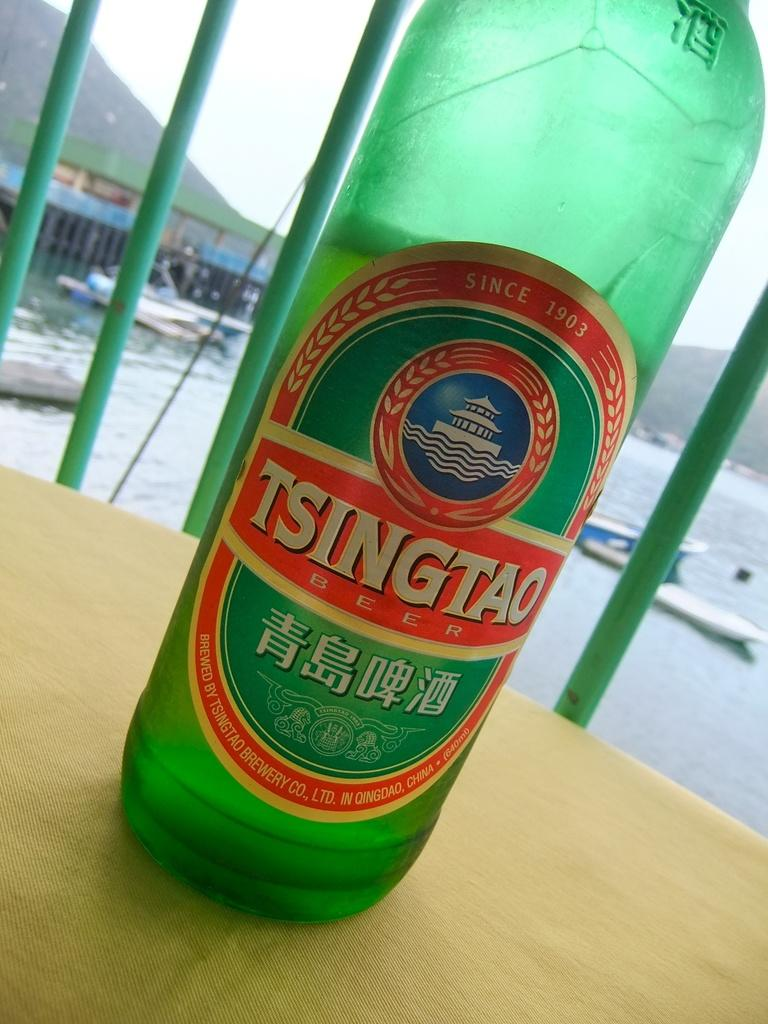<image>
Describe the image concisely. A green bottle of Tsingtao on a table. 